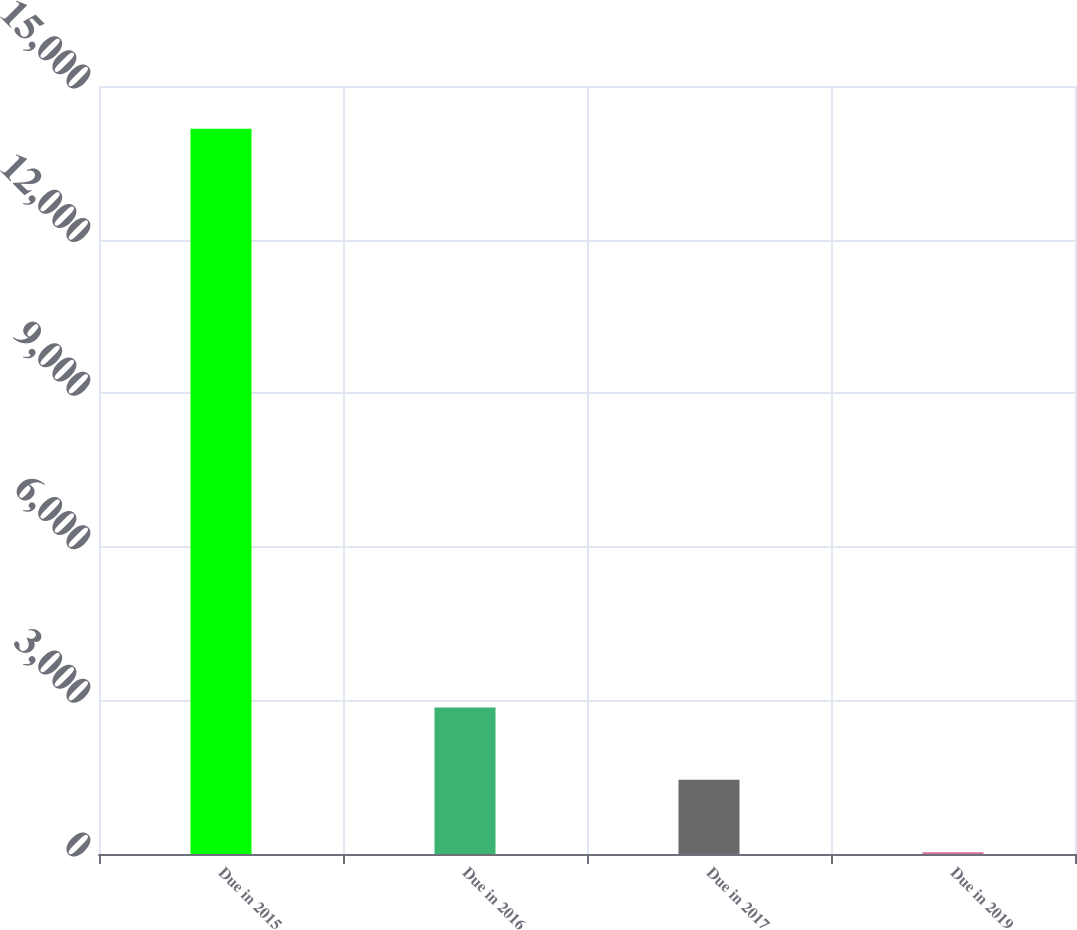Convert chart to OTSL. <chart><loc_0><loc_0><loc_500><loc_500><bar_chart><fcel>Due in 2015<fcel>Due in 2016<fcel>Due in 2017<fcel>Due in 2019<nl><fcel>14165<fcel>2861<fcel>1448<fcel>35<nl></chart> 